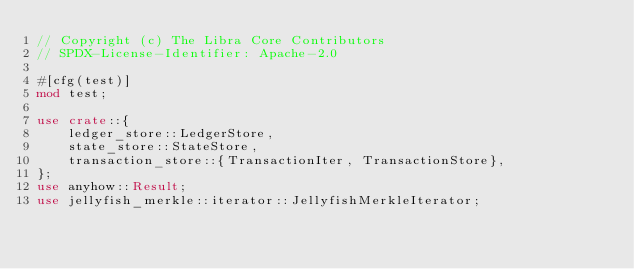<code> <loc_0><loc_0><loc_500><loc_500><_Rust_>// Copyright (c) The Libra Core Contributors
// SPDX-License-Identifier: Apache-2.0

#[cfg(test)]
mod test;

use crate::{
    ledger_store::LedgerStore,
    state_store::StateStore,
    transaction_store::{TransactionIter, TransactionStore},
};
use anyhow::Result;
use jellyfish_merkle::iterator::JellyfishMerkleIterator;</code> 